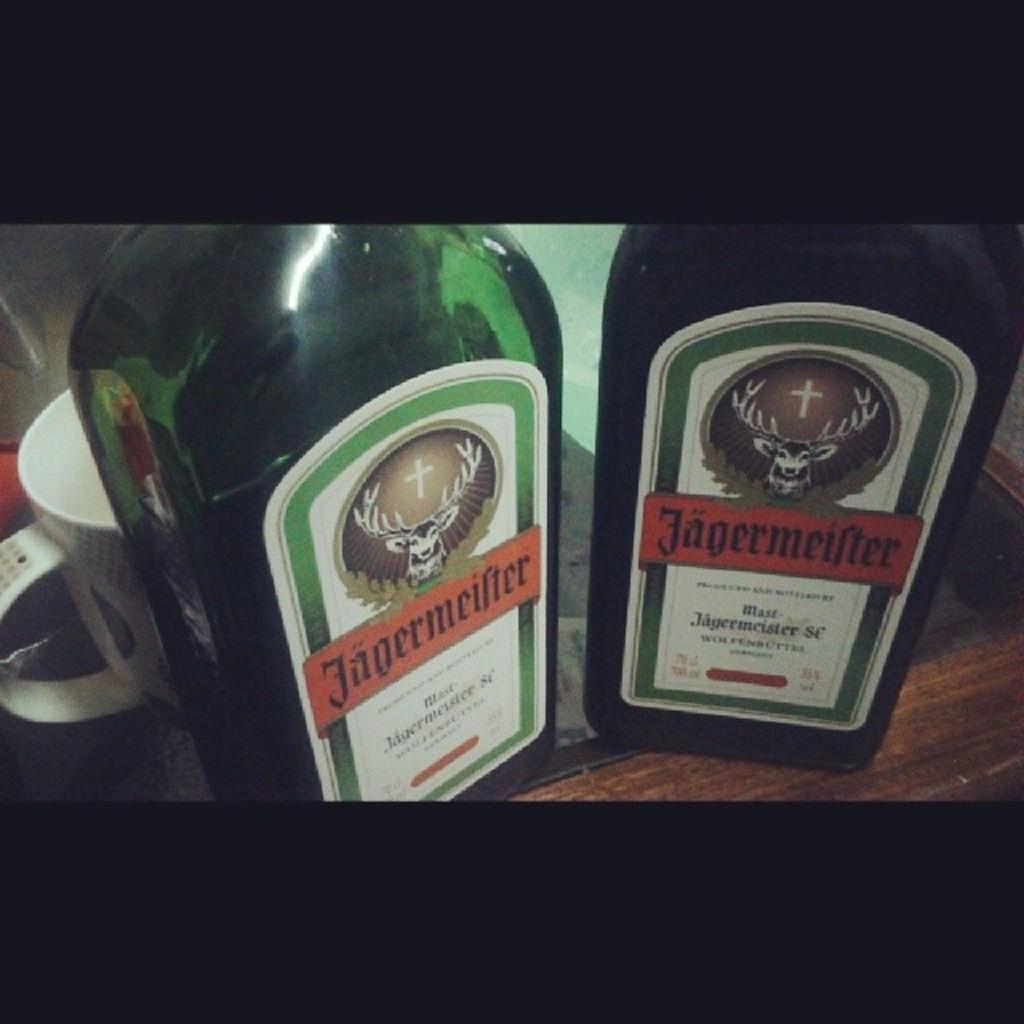What kind of drink?
Offer a terse response. Jagermeifter. 